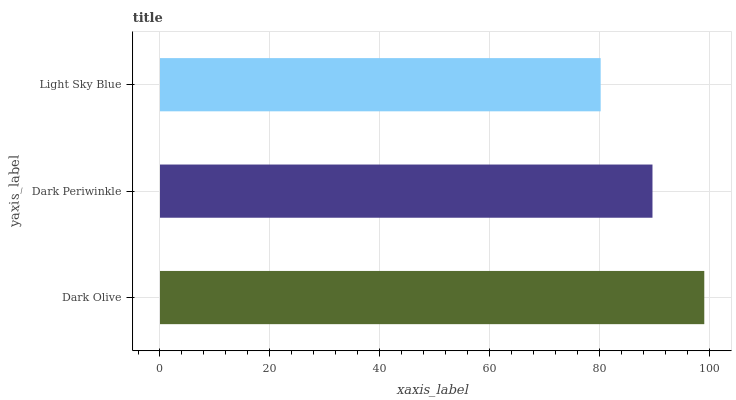Is Light Sky Blue the minimum?
Answer yes or no. Yes. Is Dark Olive the maximum?
Answer yes or no. Yes. Is Dark Periwinkle the minimum?
Answer yes or no. No. Is Dark Periwinkle the maximum?
Answer yes or no. No. Is Dark Olive greater than Dark Periwinkle?
Answer yes or no. Yes. Is Dark Periwinkle less than Dark Olive?
Answer yes or no. Yes. Is Dark Periwinkle greater than Dark Olive?
Answer yes or no. No. Is Dark Olive less than Dark Periwinkle?
Answer yes or no. No. Is Dark Periwinkle the high median?
Answer yes or no. Yes. Is Dark Periwinkle the low median?
Answer yes or no. Yes. Is Light Sky Blue the high median?
Answer yes or no. No. Is Light Sky Blue the low median?
Answer yes or no. No. 